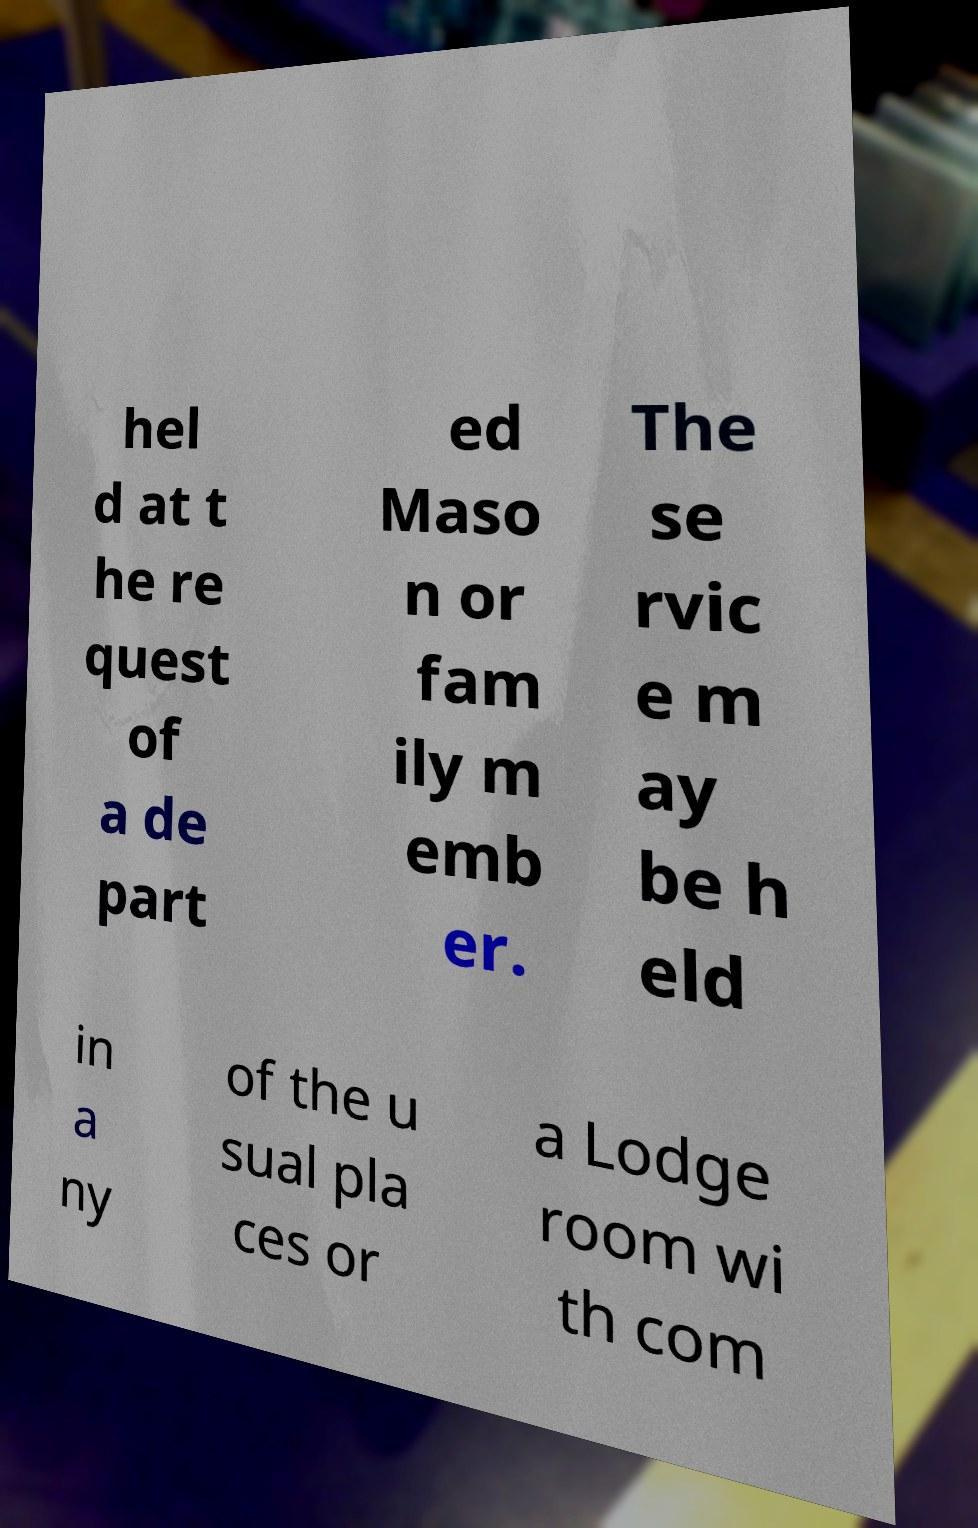Could you extract and type out the text from this image? hel d at t he re quest of a de part ed Maso n or fam ily m emb er. The se rvic e m ay be h eld in a ny of the u sual pla ces or a Lodge room wi th com 